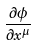<formula> <loc_0><loc_0><loc_500><loc_500>\frac { \partial \phi } { \partial x ^ { \mu } }</formula> 